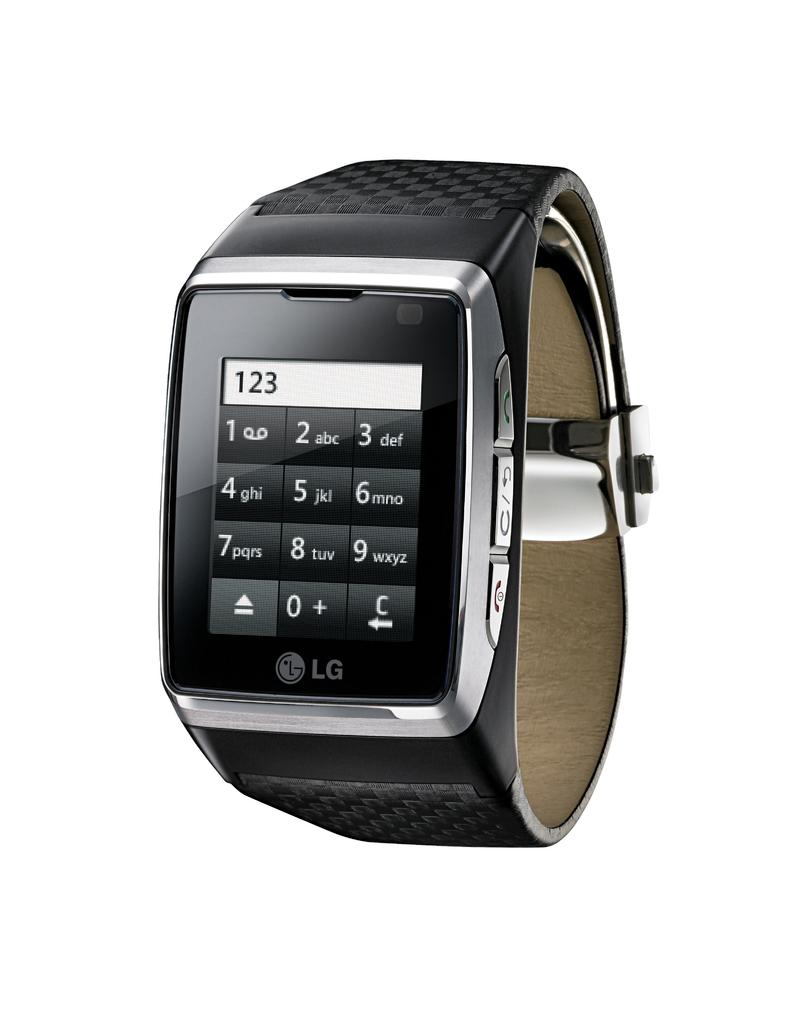Provide a one-sentence caption for the provided image. a watch that has 123 on a calculator on it. 